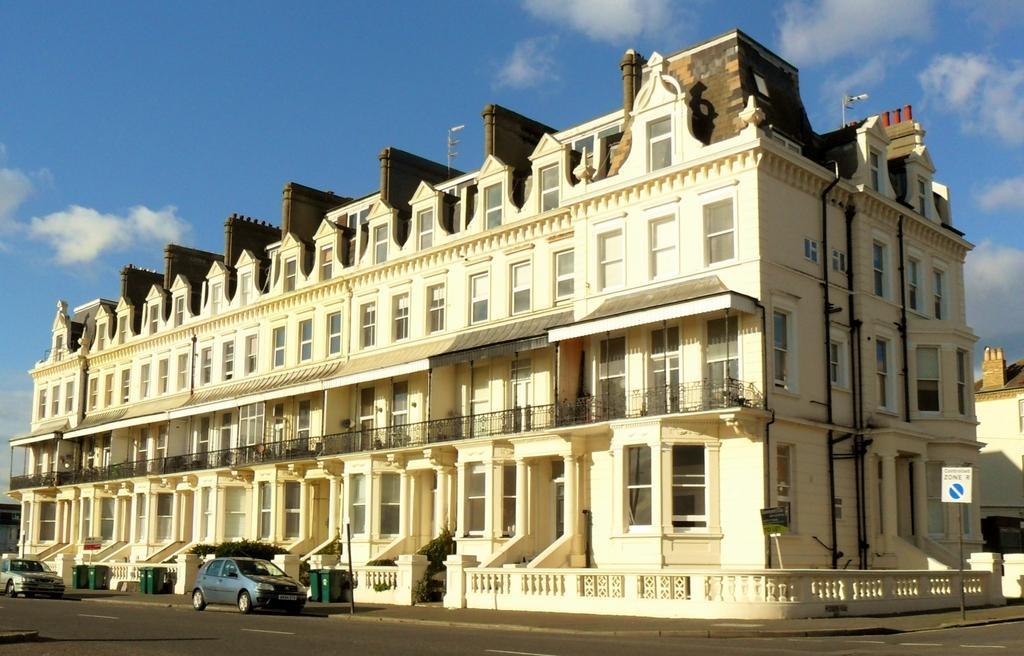In one or two sentences, can you explain what this image depicts? In this picture we see a building in front of which many vehicles are there on the road. The sky is blue. 